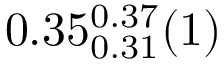<formula> <loc_0><loc_0><loc_500><loc_500>0 . 3 5 _ { 0 . 3 1 } ^ { 0 . 3 7 } ( 1 )</formula> 